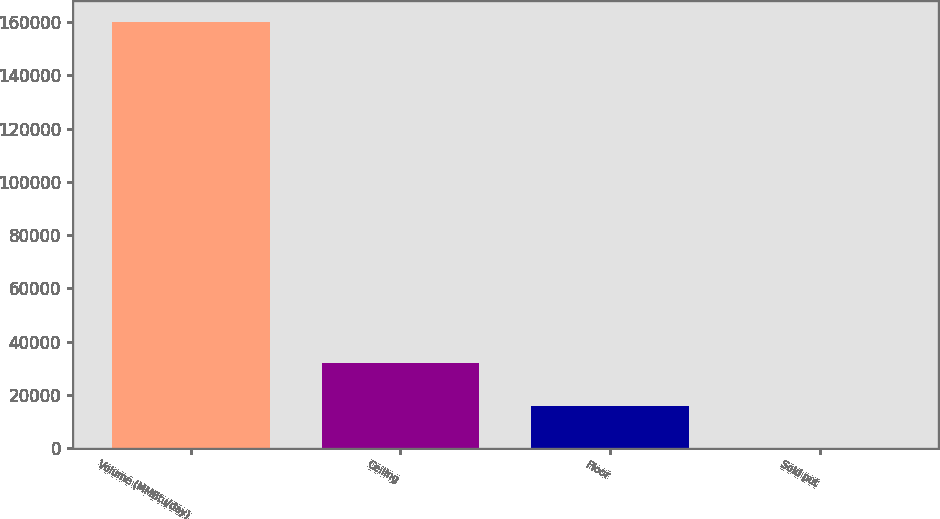Convert chart to OTSL. <chart><loc_0><loc_0><loc_500><loc_500><bar_chart><fcel>Volume (MMBtu/day)<fcel>Ceiling<fcel>Floor<fcel>Sold put<nl><fcel>160000<fcel>32002<fcel>16002.2<fcel>2.5<nl></chart> 